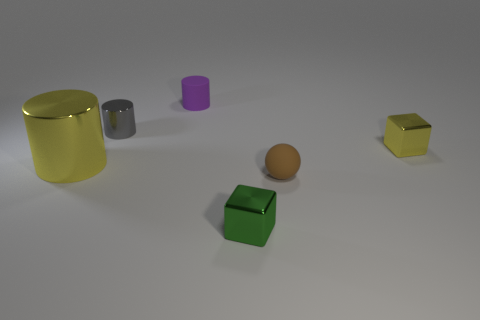Do the large thing and the tiny brown thing have the same shape? no 